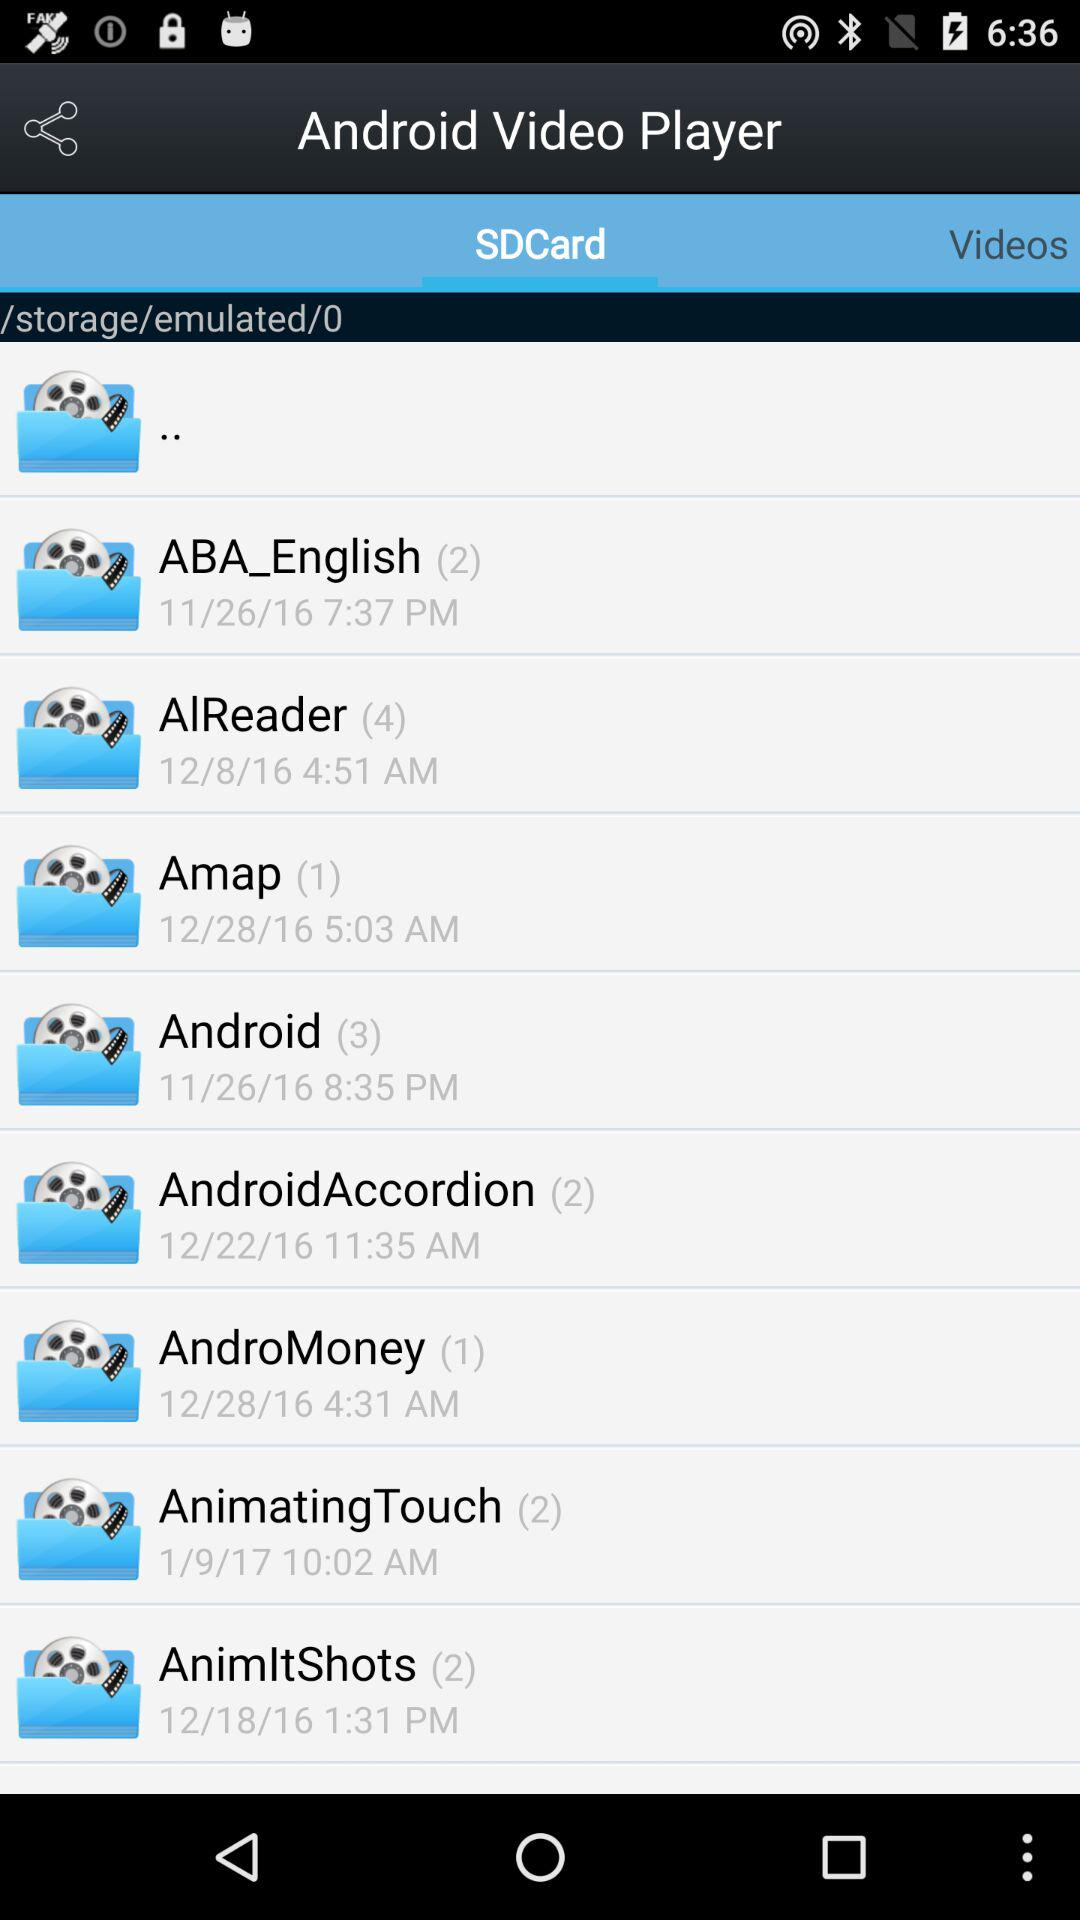How many subfolders are present in "AIReader"? There are 4 subfolders that are present in "AIReader". 